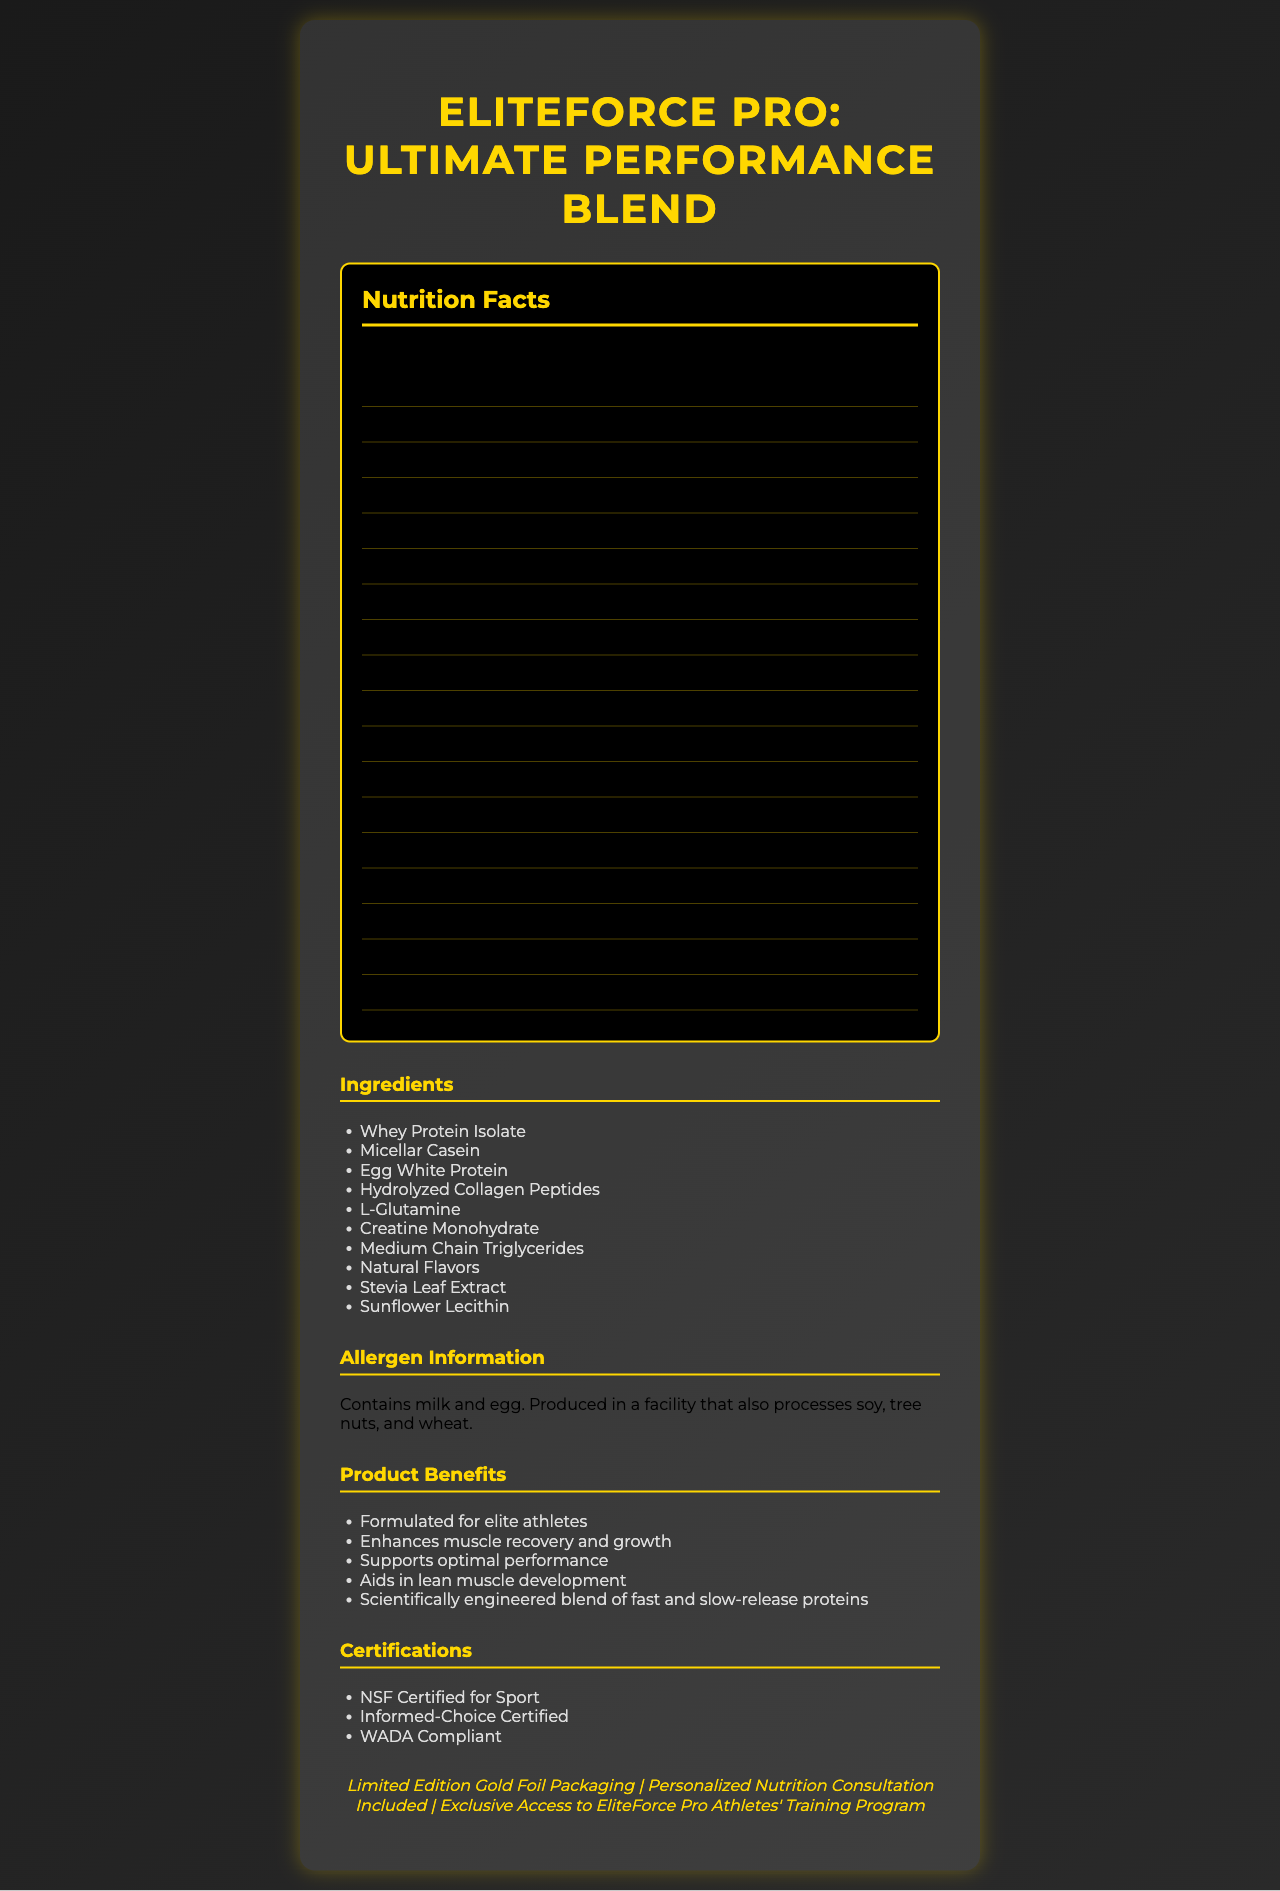what is the serving size of the protein powder? The serving size is mentioned at the top of the nutrition facts section as "1 scoop (30g)".
Answer: 1 scoop (30g) how many calories are there per serving? The calories per serving are listed as the first item under the nutrition label section.
Answer: 120 how much protein does one serving provide? The amount of protein per serving is mentioned under the protein section in the nutrition label.
Answer: 25g what is the sodium content per serving? The sodium content is listed under the sodium section in the nutrition label.
Answer: 50mg what is the daily value percentage of calcium? This information is found under the calcium section in the nutrition label.
Answer: 15% what are the main ingredients of the protein powder? The ingredients list is given in the ingredients section.
Answer: Whey Protein Isolate, Micellar Casein, Egg White Protein, Hydrolyzed Collagen Peptides, L-Glutamine, Creatine Monohydrate, Medium Chain Triglycerides, Natural Flavors, Stevia Leaf Extract, Sunflower Lecithin how many servings per container are there? The number of servings per container is stated at the top of the nutrition facts section.
Answer: 30 which of the following certifications does the product have? A. Certified Organic B. NSF Certified for Sport C. Non-GMO Project Verified D. USDA Organic The certifications listed in the document include "NSF Certified for Sport".
Answer: B what is the daily value percentage of Vitamin B12? The daily value percentage for Vitamin B12 is mentioned under the vitamin B12 section in the nutrition label.
Answer: 100% how many grams of total sugars are there per serving? The total sugars per serving are listed in the nutrition facts under total sugars.
Answer: 1g is the product formulated for elite athletes? The product claims state that it is "Formulated for elite athletes".
Answer: Yes describe the main idea of the document The document primarily serves to inform about the nutritional content, ingredients, certifications, and special features of the EliteForce Pro protein powder. It also includes key marketing claims and luxury branding elements to appeal to high-end consumers.
Answer: The document provides detailed nutritional information for EliteForce Pro: Ultimate Performance Blend, highlighting its protein and additional nutritional benefits. It lists ingredients, allergen information, and various certifications, emphasizing the product's appeal to elite athletes through luxury branding elements. how much added sugar does the product contain? The added sugars content is listed as 0g in the nutrition label.
Answer: 0g can the allergen information determine if the product is gluten-free? The allergen information only states that it contains milk and egg and is produced in a facility that processes soy, tree nuts, and wheat, but it does not specify if the product is gluten-free.
Answer: No which vitamins or minerals have a daily value of 10% or more? A. Vitamin D B. Calcium C. Iron D. Potassium E. Zinc According to the nutrition facts label, Vitamin D has a daily value of 10%, Calcium 15%, and Zinc 45%, whereas Iron and Potassium have lower values.
Answer: A. Vitamin D, B. Calcium what unique luxury elements are included with the product? The luxury branding elements are specifically listed under a separate section next to the nutrition facts.
Answer: Limited Edition Gold Foil Packaging, Personalized Nutrition Consultation Included, Exclusive Access to EliteForce Pro Athletes' Training Program is the protein content sufficient for an individual aiming for high protein intake? The protein content is 25g per serving, which is 50% of the daily value, indicating it is quite high and likely sufficient for those seeking a high protein intake.
Answer: Yes what flavor options are available for this protein powder? The document does not list any specific flavor options for the protein powder.
Answer: Cannot be determined 